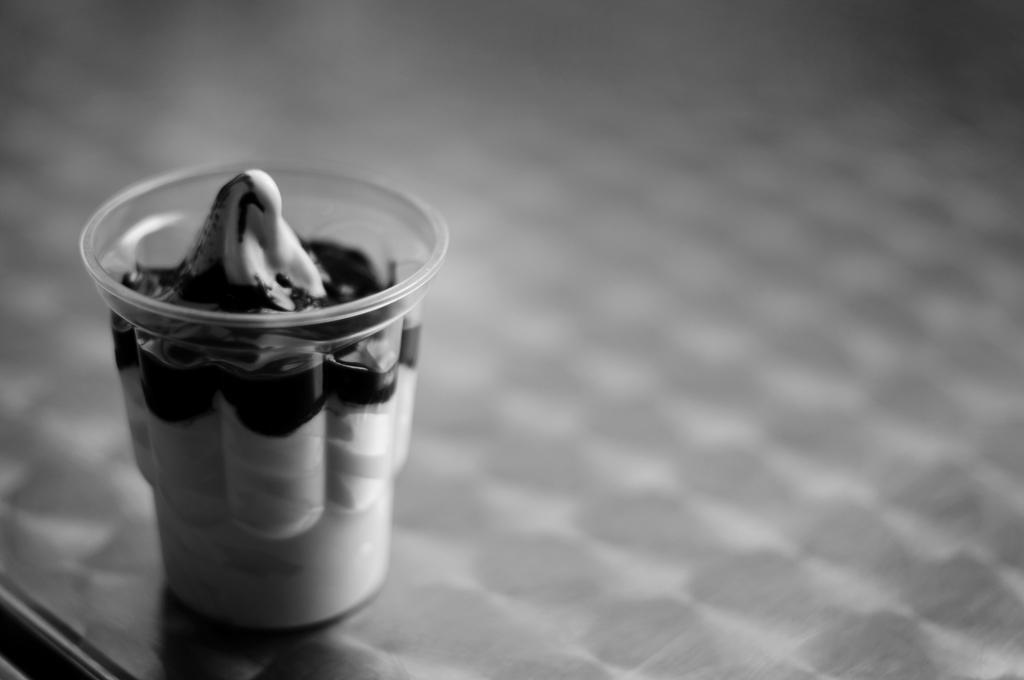In one or two sentences, can you explain what this image depicts? It is the black and white image in which there is a cup. In the cup there is cream. 